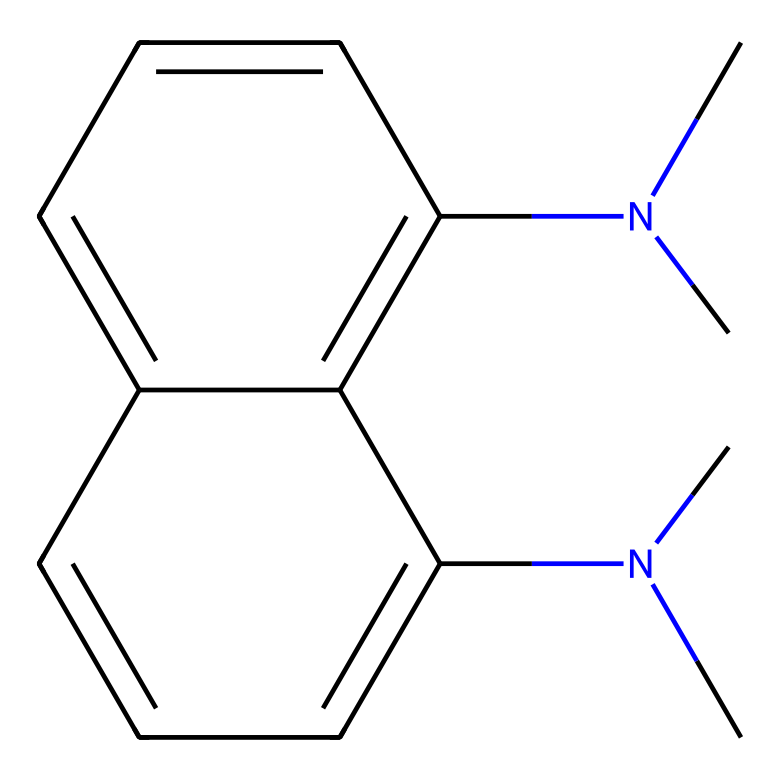How many nitrogen atoms are present in the structure? The SMILES representation indicates two nitrogen atoms, as seen by the two occurrences of "N" in the "N(C)C" groups.
Answer: two What is the total number of rings in this chemical? By analyzing the structure derived from the SMILES, there are two fused aromatic rings, which can be visually confirmed in the rendered chemical structure.
Answer: two What type of molecule is 1,8-bis(dimethylamino)naphthalene classified as? This molecule is classified as a superbase due to its ability to deprotonate acids efficiently, which is a characteristic feature of superbases.
Answer: superbase How many carbon atoms are in the naphthalene structure? In naphthalene, which consists of two fused benzene rings, there are a total of ten carbon atoms, as seen from the structure derived from the SMILES notation.
Answer: ten What functional groups are present in this molecule? The functional groups present in this molecule are dimethylamino groups, indicated by the "N(C)C" in the SMILES, which suggest availability of lone pairs for protonation.
Answer: dimethylamino groups What characteristic property is suggested by the presence of the nitrogen atoms? The presence of nitrogen atoms implies basicity, which is an important property of superbases, enabling them to accept protons easily in chemical reactions.
Answer: basicity 